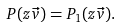Convert formula to latex. <formula><loc_0><loc_0><loc_500><loc_500>P ( z \vec { v } ) = P _ { 1 } ( z \vec { v } ) .</formula> 